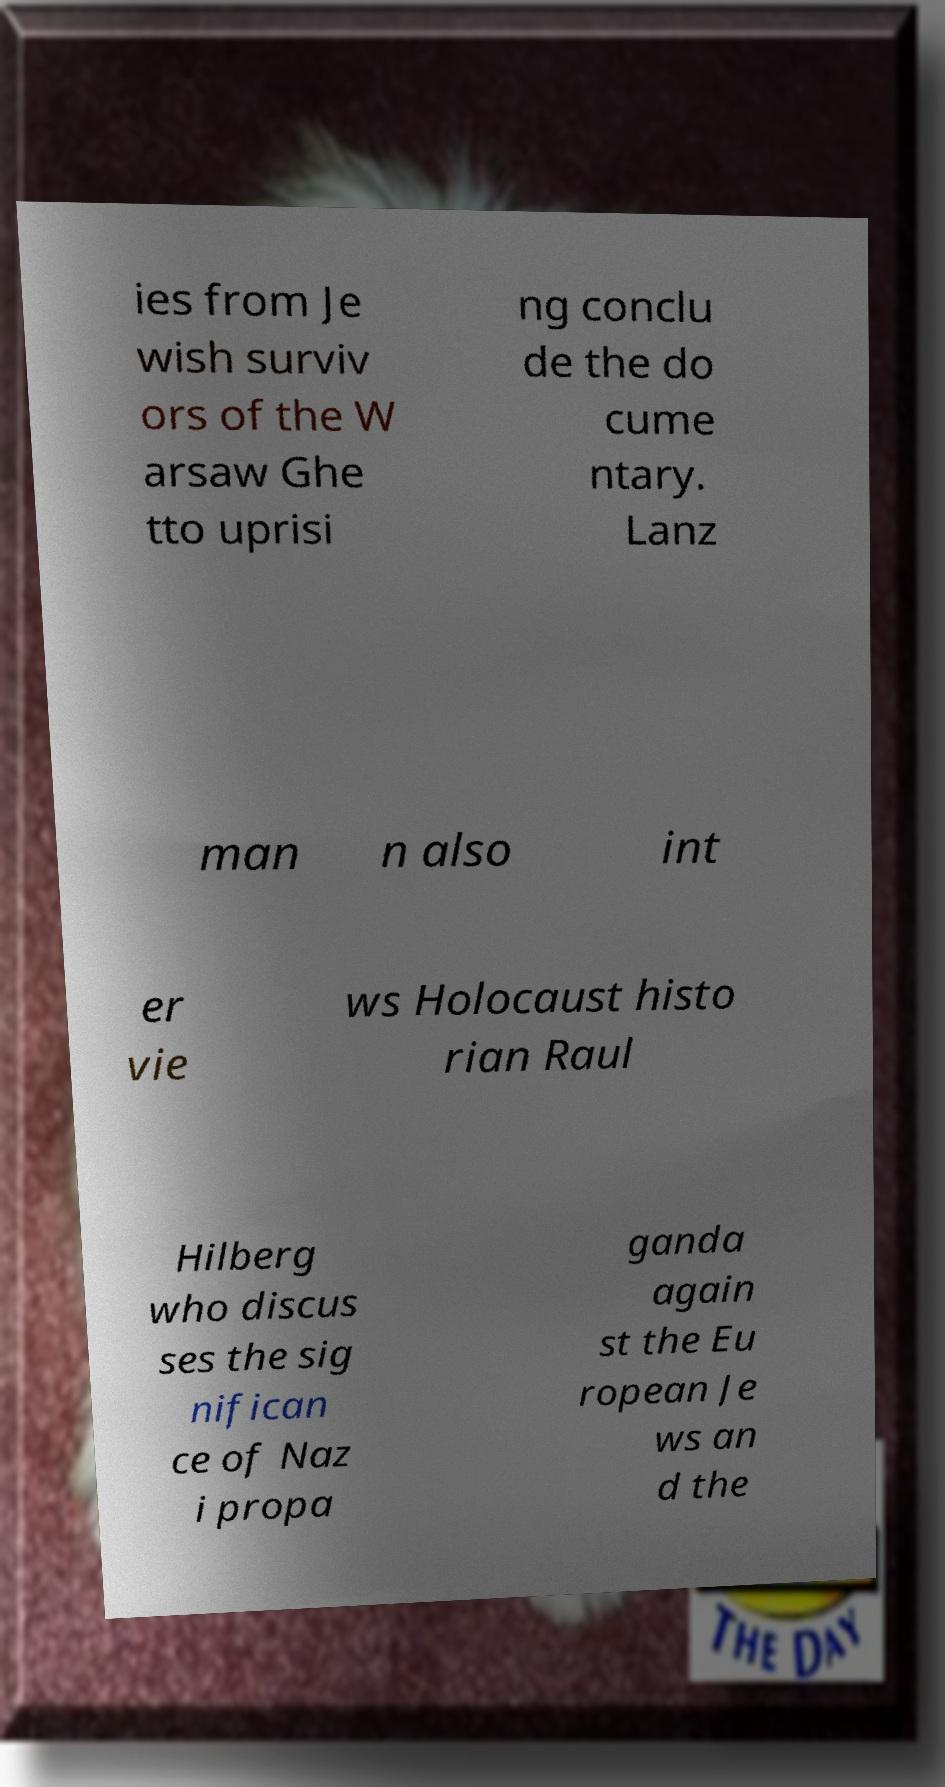There's text embedded in this image that I need extracted. Can you transcribe it verbatim? ies from Je wish surviv ors of the W arsaw Ghe tto uprisi ng conclu de the do cume ntary. Lanz man n also int er vie ws Holocaust histo rian Raul Hilberg who discus ses the sig nifican ce of Naz i propa ganda again st the Eu ropean Je ws an d the 